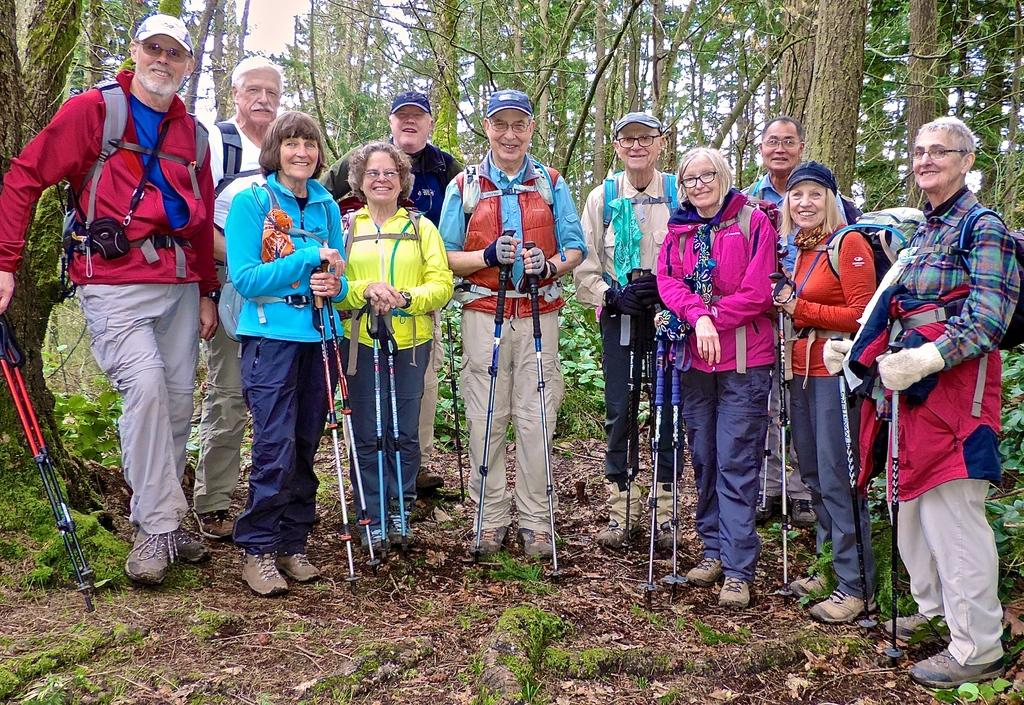What is happening in the center of the image? There are many people in the center of the image. What are the people holding in their hands? The people are holding sticks. What position are the people in? The people are standing. What can be seen in the background of the image? There are trees in the background of the image. What type of ground is visible at the bottom of the image? There is grass at the bottom of the image. What type of pipe is being traded among the people in the image? There is no pipe or trade activity depicted in the image; it shows people standing with sticks. 